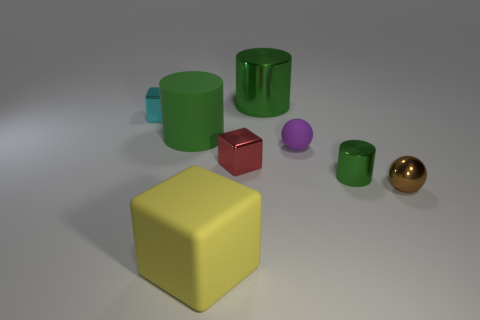What is the relative size of the objects to each other? The objects vary in size. The green cylinder and the yellow cube are significantly larger than the small blue cube and the purple sphere. The brown sphere and the red cube are the smallest objects, and the green glass is of medium size in comparison. 